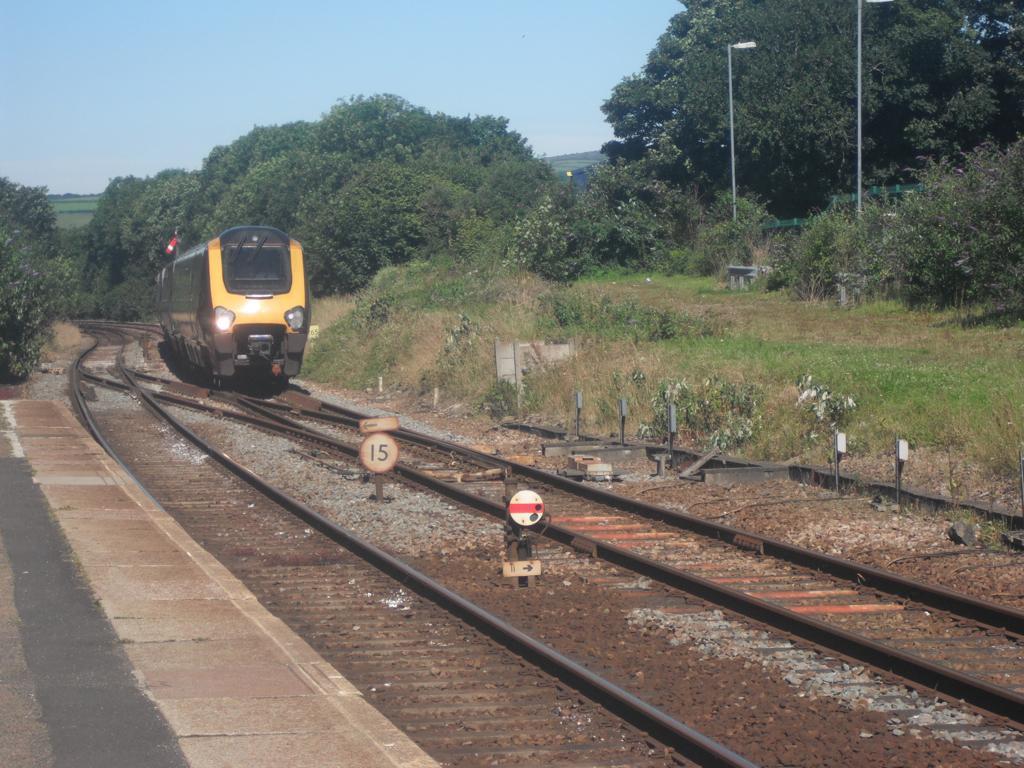Can you describe this image briefly? In this image, we can see a train is on the track. Here there is a another track. Left side of the image, we can see a platform. Background there are so many trees, plants, grass, poles and sky. 